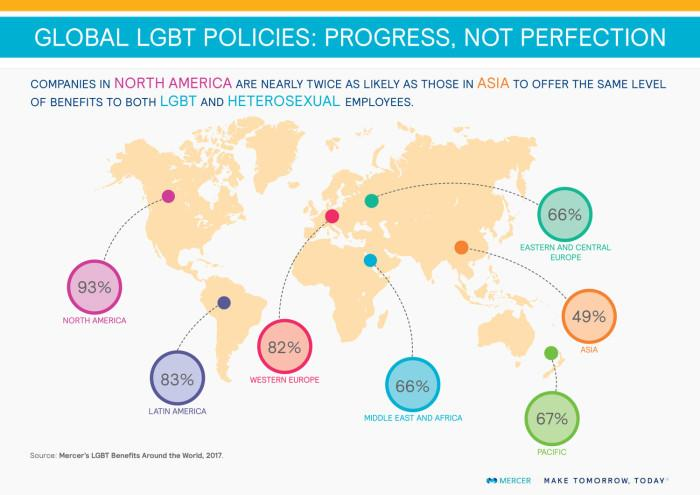Mention a couple of crucial points in this snapshot. According to a recent survey, 66% of companies in the Middle East and Africa offer the same level of benefits to both LGBT and heterosexual employees. According to a recent survey, 49% of companies in Asia offer the same level of benefits to both LGBT and heterosexual employees. According to a recent study, a large majority of companies in Western Europe, 82%, offer the same level of benefits to both LGBT and heterosexual employees. 